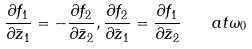<formula> <loc_0><loc_0><loc_500><loc_500>\frac { \partial { f } _ { 1 } } { \partial { \bar { z } } _ { 1 } } = - \frac { \partial { f } _ { 2 } } { \partial { \bar { z } } _ { 2 } } , \frac { \partial { f } _ { 2 } } { \partial { \bar { z } } _ { 1 } } = \frac { \partial { f } _ { 1 } } { \partial { \bar { z } } _ { 2 } } \quad a t \omega _ { 0 }</formula> 